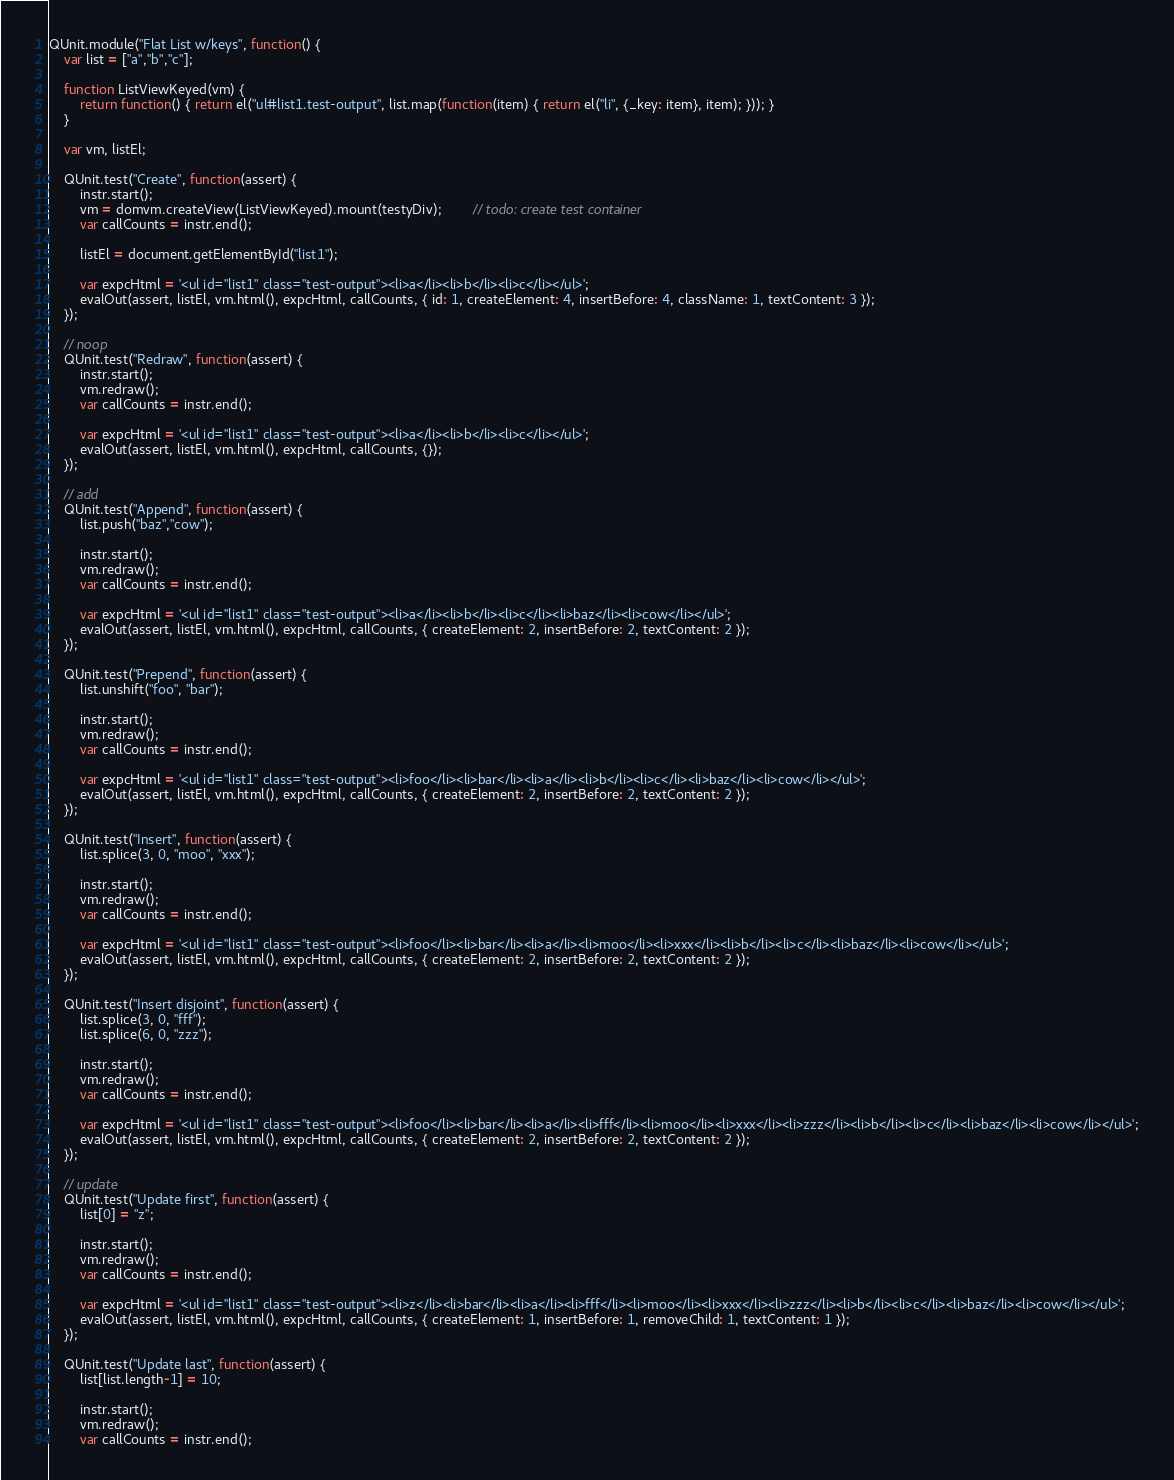<code> <loc_0><loc_0><loc_500><loc_500><_JavaScript_>QUnit.module("Flat List w/keys", function() {
	var list = ["a","b","c"];

	function ListViewKeyed(vm) {
		return function() { return el("ul#list1.test-output", list.map(function(item) { return el("li", {_key: item}, item); })); }
	}

	var vm, listEl;

	QUnit.test("Create", function(assert) {
		instr.start();
		vm = domvm.createView(ListViewKeyed).mount(testyDiv);		// todo: create test container
		var callCounts = instr.end();

		listEl = document.getElementById("list1");

		var expcHtml = '<ul id="list1" class="test-output"><li>a</li><li>b</li><li>c</li></ul>';
		evalOut(assert, listEl, vm.html(), expcHtml, callCounts, { id: 1, createElement: 4, insertBefore: 4, className: 1, textContent: 3 });
	});

	// noop
	QUnit.test("Redraw", function(assert) {
		instr.start();
		vm.redraw();
		var callCounts = instr.end();

		var expcHtml = '<ul id="list1" class="test-output"><li>a</li><li>b</li><li>c</li></ul>';
		evalOut(assert, listEl, vm.html(), expcHtml, callCounts, {});
	});

	// add
	QUnit.test("Append", function(assert) {
		list.push("baz","cow");

		instr.start();
		vm.redraw();
		var callCounts = instr.end();

		var expcHtml = '<ul id="list1" class="test-output"><li>a</li><li>b</li><li>c</li><li>baz</li><li>cow</li></ul>';
		evalOut(assert, listEl, vm.html(), expcHtml, callCounts, { createElement: 2, insertBefore: 2, textContent: 2 });
	});

	QUnit.test("Prepend", function(assert) {
		list.unshift("foo", "bar");

		instr.start();
		vm.redraw();
		var callCounts = instr.end();

		var expcHtml = '<ul id="list1" class="test-output"><li>foo</li><li>bar</li><li>a</li><li>b</li><li>c</li><li>baz</li><li>cow</li></ul>';
		evalOut(assert, listEl, vm.html(), expcHtml, callCounts, { createElement: 2, insertBefore: 2, textContent: 2 });
	});

	QUnit.test("Insert", function(assert) {
		list.splice(3, 0, "moo", "xxx");

		instr.start();
		vm.redraw();
		var callCounts = instr.end();

		var expcHtml = '<ul id="list1" class="test-output"><li>foo</li><li>bar</li><li>a</li><li>moo</li><li>xxx</li><li>b</li><li>c</li><li>baz</li><li>cow</li></ul>';
		evalOut(assert, listEl, vm.html(), expcHtml, callCounts, { createElement: 2, insertBefore: 2, textContent: 2 });
	});

	QUnit.test("Insert disjoint", function(assert) {
		list.splice(3, 0, "fff");
		list.splice(6, 0, "zzz");

		instr.start();
		vm.redraw();
		var callCounts = instr.end();

		var expcHtml = '<ul id="list1" class="test-output"><li>foo</li><li>bar</li><li>a</li><li>fff</li><li>moo</li><li>xxx</li><li>zzz</li><li>b</li><li>c</li><li>baz</li><li>cow</li></ul>';
		evalOut(assert, listEl, vm.html(), expcHtml, callCounts, { createElement: 2, insertBefore: 2, textContent: 2 });
	});

	// update
	QUnit.test("Update first", function(assert) {
		list[0] = "z";

		instr.start();
		vm.redraw();
		var callCounts = instr.end();

		var expcHtml = '<ul id="list1" class="test-output"><li>z</li><li>bar</li><li>a</li><li>fff</li><li>moo</li><li>xxx</li><li>zzz</li><li>b</li><li>c</li><li>baz</li><li>cow</li></ul>';
		evalOut(assert, listEl, vm.html(), expcHtml, callCounts, { createElement: 1, insertBefore: 1, removeChild: 1, textContent: 1 });
	});

	QUnit.test("Update last", function(assert) {
		list[list.length-1] = 10;

		instr.start();
		vm.redraw();
		var callCounts = instr.end();
</code> 